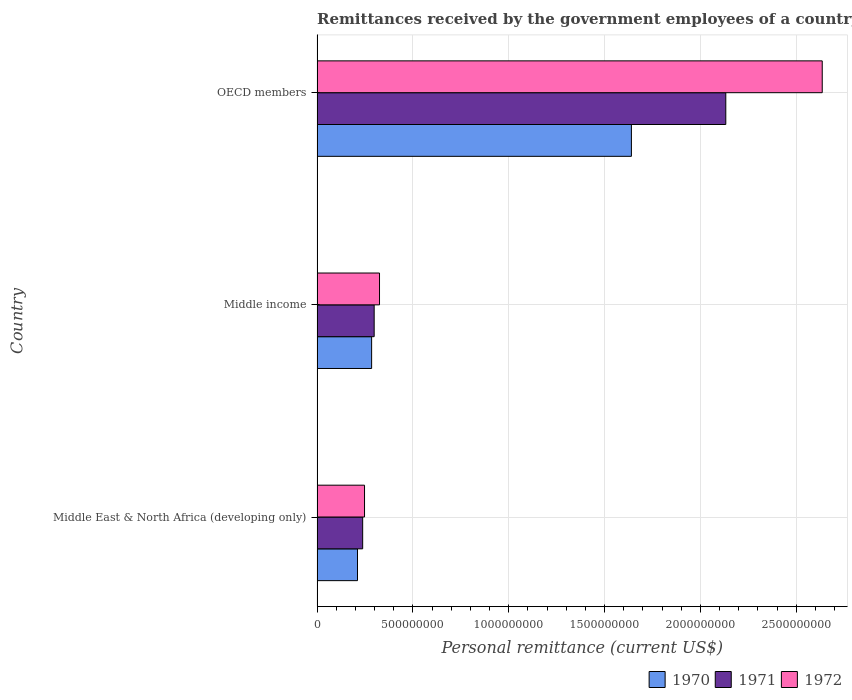Are the number of bars per tick equal to the number of legend labels?
Offer a very short reply. Yes. How many bars are there on the 3rd tick from the top?
Give a very brief answer. 3. What is the label of the 2nd group of bars from the top?
Give a very brief answer. Middle income. What is the remittances received by the government employees in 1971 in OECD members?
Your answer should be very brief. 2.13e+09. Across all countries, what is the maximum remittances received by the government employees in 1972?
Provide a succinct answer. 2.64e+09. Across all countries, what is the minimum remittances received by the government employees in 1971?
Provide a short and direct response. 2.38e+08. In which country was the remittances received by the government employees in 1970 minimum?
Your answer should be very brief. Middle East & North Africa (developing only). What is the total remittances received by the government employees in 1970 in the graph?
Offer a very short reply. 2.14e+09. What is the difference between the remittances received by the government employees in 1971 in Middle East & North Africa (developing only) and that in OECD members?
Give a very brief answer. -1.89e+09. What is the difference between the remittances received by the government employees in 1972 in Middle income and the remittances received by the government employees in 1971 in OECD members?
Offer a terse response. -1.81e+09. What is the average remittances received by the government employees in 1970 per country?
Provide a succinct answer. 7.12e+08. What is the difference between the remittances received by the government employees in 1972 and remittances received by the government employees in 1970 in OECD members?
Ensure brevity in your answer.  9.96e+08. In how many countries, is the remittances received by the government employees in 1970 greater than 1700000000 US$?
Make the answer very short. 0. What is the ratio of the remittances received by the government employees in 1972 in Middle income to that in OECD members?
Offer a very short reply. 0.12. Is the difference between the remittances received by the government employees in 1972 in Middle East & North Africa (developing only) and OECD members greater than the difference between the remittances received by the government employees in 1970 in Middle East & North Africa (developing only) and OECD members?
Your answer should be compact. No. What is the difference between the highest and the second highest remittances received by the government employees in 1972?
Your answer should be compact. 2.31e+09. What is the difference between the highest and the lowest remittances received by the government employees in 1971?
Ensure brevity in your answer.  1.89e+09. What does the 3rd bar from the top in Middle income represents?
Your response must be concise. 1970. What does the 2nd bar from the bottom in OECD members represents?
Offer a very short reply. 1971. Are all the bars in the graph horizontal?
Provide a short and direct response. Yes. How many countries are there in the graph?
Offer a very short reply. 3. What is the difference between two consecutive major ticks on the X-axis?
Keep it short and to the point. 5.00e+08. Where does the legend appear in the graph?
Offer a terse response. Bottom right. How are the legend labels stacked?
Offer a terse response. Horizontal. What is the title of the graph?
Your answer should be very brief. Remittances received by the government employees of a country. What is the label or title of the X-axis?
Offer a very short reply. Personal remittance (current US$). What is the label or title of the Y-axis?
Your response must be concise. Country. What is the Personal remittance (current US$) in 1970 in Middle East & North Africa (developing only)?
Provide a short and direct response. 2.11e+08. What is the Personal remittance (current US$) in 1971 in Middle East & North Africa (developing only)?
Offer a terse response. 2.38e+08. What is the Personal remittance (current US$) in 1972 in Middle East & North Africa (developing only)?
Provide a short and direct response. 2.48e+08. What is the Personal remittance (current US$) in 1970 in Middle income?
Offer a very short reply. 2.85e+08. What is the Personal remittance (current US$) in 1971 in Middle income?
Offer a very short reply. 2.98e+08. What is the Personal remittance (current US$) in 1972 in Middle income?
Ensure brevity in your answer.  3.26e+08. What is the Personal remittance (current US$) of 1970 in OECD members?
Ensure brevity in your answer.  1.64e+09. What is the Personal remittance (current US$) in 1971 in OECD members?
Your response must be concise. 2.13e+09. What is the Personal remittance (current US$) in 1972 in OECD members?
Your answer should be compact. 2.64e+09. Across all countries, what is the maximum Personal remittance (current US$) in 1970?
Ensure brevity in your answer.  1.64e+09. Across all countries, what is the maximum Personal remittance (current US$) of 1971?
Make the answer very short. 2.13e+09. Across all countries, what is the maximum Personal remittance (current US$) of 1972?
Ensure brevity in your answer.  2.64e+09. Across all countries, what is the minimum Personal remittance (current US$) in 1970?
Make the answer very short. 2.11e+08. Across all countries, what is the minimum Personal remittance (current US$) of 1971?
Give a very brief answer. 2.38e+08. Across all countries, what is the minimum Personal remittance (current US$) of 1972?
Ensure brevity in your answer.  2.48e+08. What is the total Personal remittance (current US$) in 1970 in the graph?
Offer a very short reply. 2.14e+09. What is the total Personal remittance (current US$) in 1971 in the graph?
Your answer should be compact. 2.67e+09. What is the total Personal remittance (current US$) in 1972 in the graph?
Offer a terse response. 3.21e+09. What is the difference between the Personal remittance (current US$) of 1970 in Middle East & North Africa (developing only) and that in Middle income?
Provide a short and direct response. -7.38e+07. What is the difference between the Personal remittance (current US$) of 1971 in Middle East & North Africa (developing only) and that in Middle income?
Offer a very short reply. -6.00e+07. What is the difference between the Personal remittance (current US$) of 1972 in Middle East & North Africa (developing only) and that in Middle income?
Your answer should be compact. -7.81e+07. What is the difference between the Personal remittance (current US$) of 1970 in Middle East & North Africa (developing only) and that in OECD members?
Your answer should be compact. -1.43e+09. What is the difference between the Personal remittance (current US$) in 1971 in Middle East & North Africa (developing only) and that in OECD members?
Offer a very short reply. -1.89e+09. What is the difference between the Personal remittance (current US$) in 1972 in Middle East & North Africa (developing only) and that in OECD members?
Give a very brief answer. -2.39e+09. What is the difference between the Personal remittance (current US$) in 1970 in Middle income and that in OECD members?
Your answer should be very brief. -1.36e+09. What is the difference between the Personal remittance (current US$) of 1971 in Middle income and that in OECD members?
Ensure brevity in your answer.  -1.83e+09. What is the difference between the Personal remittance (current US$) in 1972 in Middle income and that in OECD members?
Keep it short and to the point. -2.31e+09. What is the difference between the Personal remittance (current US$) of 1970 in Middle East & North Africa (developing only) and the Personal remittance (current US$) of 1971 in Middle income?
Your response must be concise. -8.70e+07. What is the difference between the Personal remittance (current US$) in 1970 in Middle East & North Africa (developing only) and the Personal remittance (current US$) in 1972 in Middle income?
Your response must be concise. -1.15e+08. What is the difference between the Personal remittance (current US$) of 1971 in Middle East & North Africa (developing only) and the Personal remittance (current US$) of 1972 in Middle income?
Your response must be concise. -8.79e+07. What is the difference between the Personal remittance (current US$) of 1970 in Middle East & North Africa (developing only) and the Personal remittance (current US$) of 1971 in OECD members?
Provide a succinct answer. -1.92e+09. What is the difference between the Personal remittance (current US$) of 1970 in Middle East & North Africa (developing only) and the Personal remittance (current US$) of 1972 in OECD members?
Make the answer very short. -2.42e+09. What is the difference between the Personal remittance (current US$) of 1971 in Middle East & North Africa (developing only) and the Personal remittance (current US$) of 1972 in OECD members?
Ensure brevity in your answer.  -2.40e+09. What is the difference between the Personal remittance (current US$) in 1970 in Middle income and the Personal remittance (current US$) in 1971 in OECD members?
Offer a very short reply. -1.85e+09. What is the difference between the Personal remittance (current US$) in 1970 in Middle income and the Personal remittance (current US$) in 1972 in OECD members?
Provide a succinct answer. -2.35e+09. What is the difference between the Personal remittance (current US$) of 1971 in Middle income and the Personal remittance (current US$) of 1972 in OECD members?
Provide a short and direct response. -2.34e+09. What is the average Personal remittance (current US$) in 1970 per country?
Keep it short and to the point. 7.12e+08. What is the average Personal remittance (current US$) of 1971 per country?
Your answer should be compact. 8.90e+08. What is the average Personal remittance (current US$) in 1972 per country?
Provide a succinct answer. 1.07e+09. What is the difference between the Personal remittance (current US$) of 1970 and Personal remittance (current US$) of 1971 in Middle East & North Africa (developing only)?
Offer a very short reply. -2.70e+07. What is the difference between the Personal remittance (current US$) of 1970 and Personal remittance (current US$) of 1972 in Middle East & North Africa (developing only)?
Keep it short and to the point. -3.67e+07. What is the difference between the Personal remittance (current US$) in 1971 and Personal remittance (current US$) in 1972 in Middle East & North Africa (developing only)?
Ensure brevity in your answer.  -9.72e+06. What is the difference between the Personal remittance (current US$) of 1970 and Personal remittance (current US$) of 1971 in Middle income?
Offer a very short reply. -1.32e+07. What is the difference between the Personal remittance (current US$) in 1970 and Personal remittance (current US$) in 1972 in Middle income?
Make the answer very short. -4.11e+07. What is the difference between the Personal remittance (current US$) of 1971 and Personal remittance (current US$) of 1972 in Middle income?
Your answer should be very brief. -2.79e+07. What is the difference between the Personal remittance (current US$) of 1970 and Personal remittance (current US$) of 1971 in OECD members?
Make the answer very short. -4.92e+08. What is the difference between the Personal remittance (current US$) in 1970 and Personal remittance (current US$) in 1972 in OECD members?
Provide a short and direct response. -9.96e+08. What is the difference between the Personal remittance (current US$) in 1971 and Personal remittance (current US$) in 1972 in OECD members?
Offer a very short reply. -5.03e+08. What is the ratio of the Personal remittance (current US$) of 1970 in Middle East & North Africa (developing only) to that in Middle income?
Make the answer very short. 0.74. What is the ratio of the Personal remittance (current US$) of 1971 in Middle East & North Africa (developing only) to that in Middle income?
Make the answer very short. 0.8. What is the ratio of the Personal remittance (current US$) in 1972 in Middle East & North Africa (developing only) to that in Middle income?
Your response must be concise. 0.76. What is the ratio of the Personal remittance (current US$) in 1970 in Middle East & North Africa (developing only) to that in OECD members?
Make the answer very short. 0.13. What is the ratio of the Personal remittance (current US$) of 1971 in Middle East & North Africa (developing only) to that in OECD members?
Ensure brevity in your answer.  0.11. What is the ratio of the Personal remittance (current US$) of 1972 in Middle East & North Africa (developing only) to that in OECD members?
Ensure brevity in your answer.  0.09. What is the ratio of the Personal remittance (current US$) in 1970 in Middle income to that in OECD members?
Your answer should be very brief. 0.17. What is the ratio of the Personal remittance (current US$) in 1971 in Middle income to that in OECD members?
Provide a short and direct response. 0.14. What is the ratio of the Personal remittance (current US$) of 1972 in Middle income to that in OECD members?
Offer a very short reply. 0.12. What is the difference between the highest and the second highest Personal remittance (current US$) in 1970?
Keep it short and to the point. 1.36e+09. What is the difference between the highest and the second highest Personal remittance (current US$) in 1971?
Make the answer very short. 1.83e+09. What is the difference between the highest and the second highest Personal remittance (current US$) of 1972?
Your answer should be compact. 2.31e+09. What is the difference between the highest and the lowest Personal remittance (current US$) of 1970?
Give a very brief answer. 1.43e+09. What is the difference between the highest and the lowest Personal remittance (current US$) in 1971?
Your answer should be compact. 1.89e+09. What is the difference between the highest and the lowest Personal remittance (current US$) in 1972?
Your answer should be very brief. 2.39e+09. 